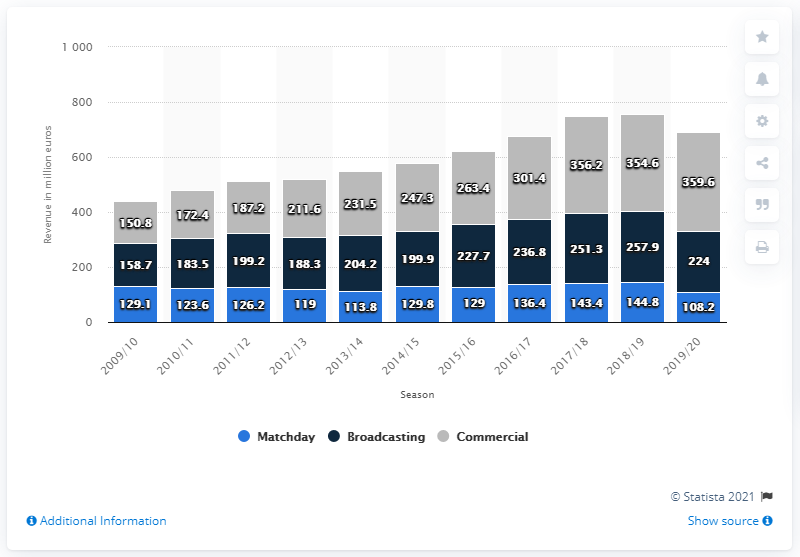List a handful of essential elements in this visual. The value of broadcasting in 2019/2020 was 224. In the 2019/2020 fiscal year, Real Madrid earned approximately 359.6 million euros from sponsorship and merchandising. 